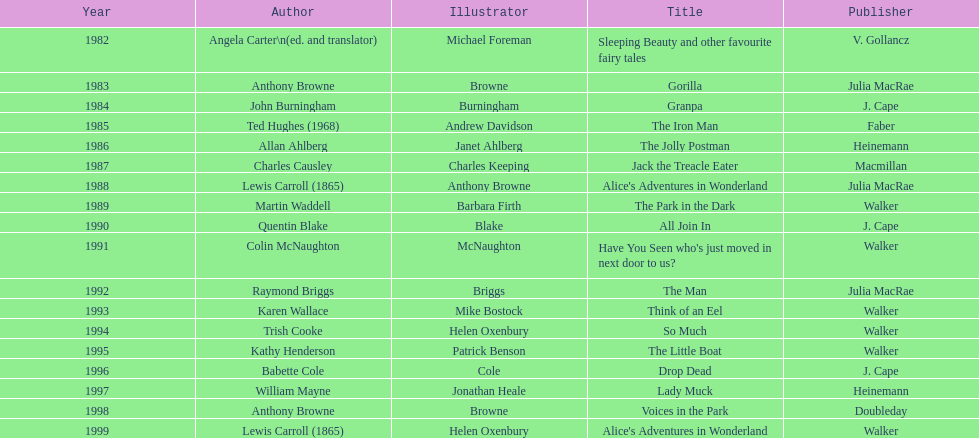Who wrote the debut piece that received an award? Angela Carter. 